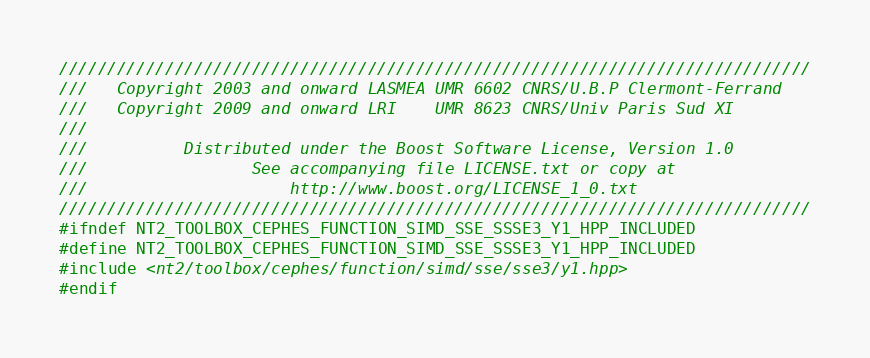<code> <loc_0><loc_0><loc_500><loc_500><_C++_>//////////////////////////////////////////////////////////////////////////////
///   Copyright 2003 and onward LASMEA UMR 6602 CNRS/U.B.P Clermont-Ferrand
///   Copyright 2009 and onward LRI    UMR 8623 CNRS/Univ Paris Sud XI
///
///          Distributed under the Boost Software License, Version 1.0
///                 See accompanying file LICENSE.txt or copy at
///                     http://www.boost.org/LICENSE_1_0.txt
//////////////////////////////////////////////////////////////////////////////
#ifndef NT2_TOOLBOX_CEPHES_FUNCTION_SIMD_SSE_SSSE3_Y1_HPP_INCLUDED
#define NT2_TOOLBOX_CEPHES_FUNCTION_SIMD_SSE_SSSE3_Y1_HPP_INCLUDED
#include <nt2/toolbox/cephes/function/simd/sse/sse3/y1.hpp>
#endif
</code> 